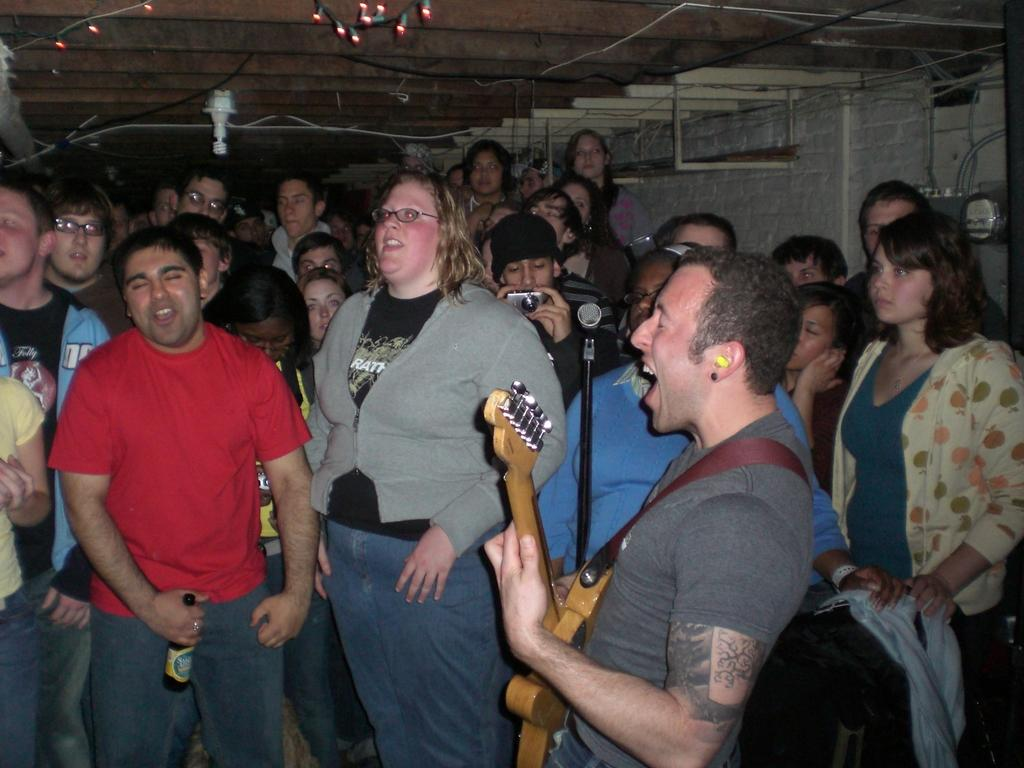What is the man in the image doing? The man is using a guitar and singing on a mic. What instrument is the man playing in the image? The man is playing a guitar. Are there any other people in the image besides the man? Yes, there are people looking at the man. What can be seen above the ceiling in the image? There are lights visible over the ceiling. What type of quarter is being used to play the guitar in the image? There is no quarter being used to play the guitar in the image; the man is using his hands to play the instrument. 